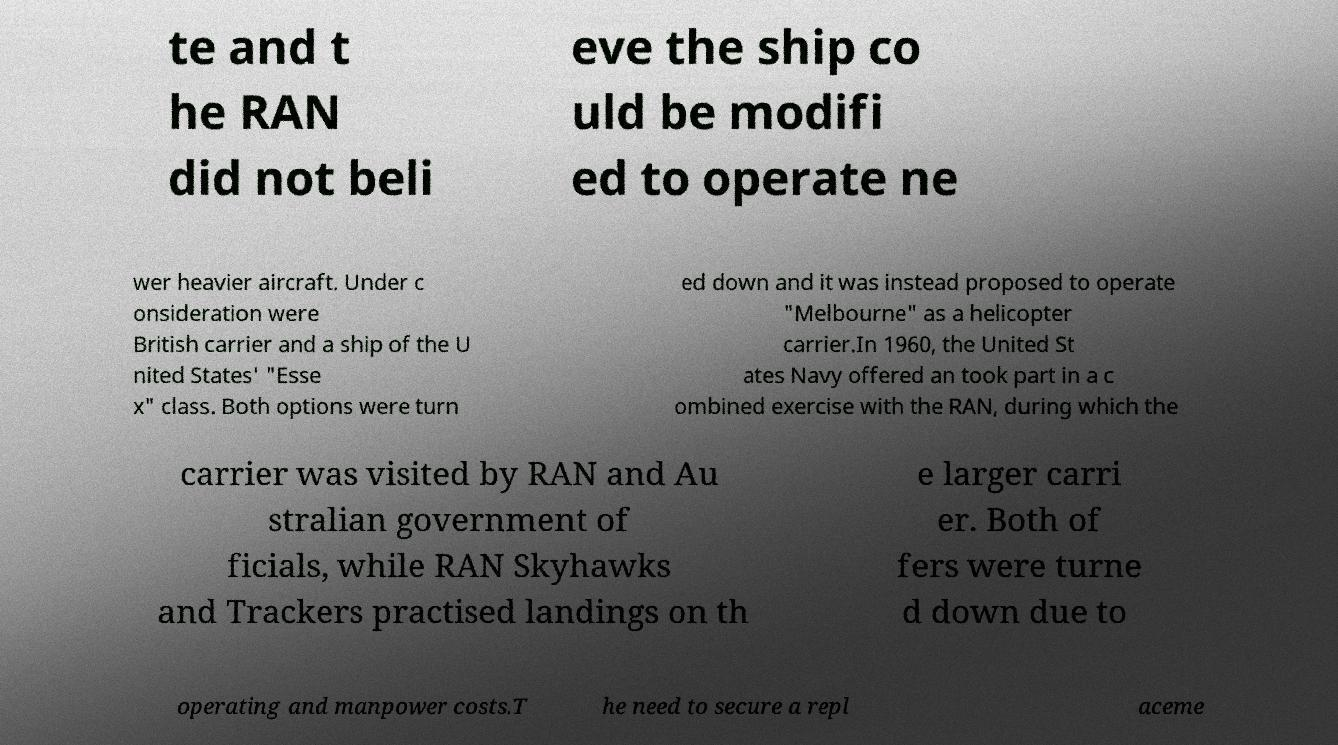There's text embedded in this image that I need extracted. Can you transcribe it verbatim? te and t he RAN did not beli eve the ship co uld be modifi ed to operate ne wer heavier aircraft. Under c onsideration were British carrier and a ship of the U nited States' "Esse x" class. Both options were turn ed down and it was instead proposed to operate "Melbourne" as a helicopter carrier.In 1960, the United St ates Navy offered an took part in a c ombined exercise with the RAN, during which the carrier was visited by RAN and Au stralian government of ficials, while RAN Skyhawks and Trackers practised landings on th e larger carri er. Both of fers were turne d down due to operating and manpower costs.T he need to secure a repl aceme 